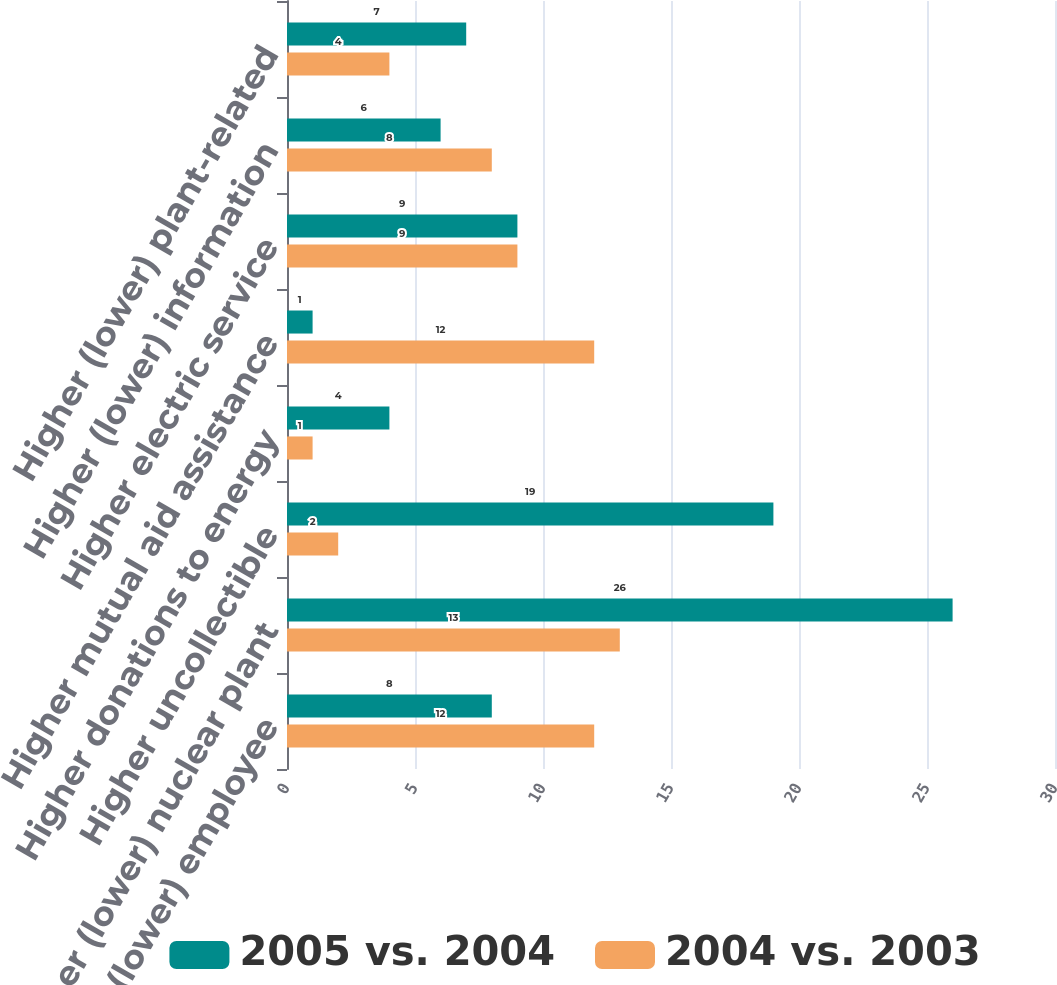<chart> <loc_0><loc_0><loc_500><loc_500><stacked_bar_chart><ecel><fcel>Higher (lower) employee<fcel>Higher (lower) nuclear plant<fcel>Higher uncollectible<fcel>Higher donations to energy<fcel>Higher mutual aid assistance<fcel>Higher electric service<fcel>Higher (lower) information<fcel>Higher (lower) plant-related<nl><fcel>2005 vs. 2004<fcel>8<fcel>26<fcel>19<fcel>4<fcel>1<fcel>9<fcel>6<fcel>7<nl><fcel>2004 vs. 2003<fcel>12<fcel>13<fcel>2<fcel>1<fcel>12<fcel>9<fcel>8<fcel>4<nl></chart> 